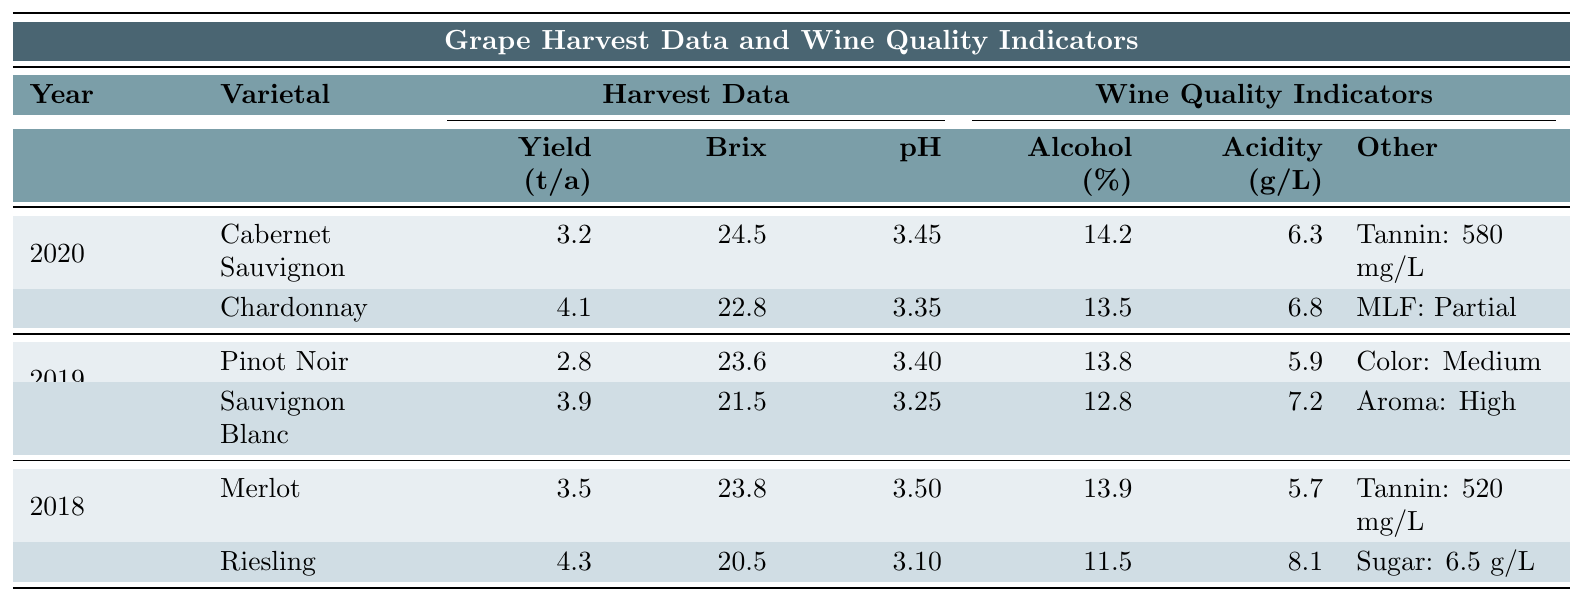What is the yield of Chardonnay in 2020? The yield for Chardonnay in 2020 is specifically listed in the table under the Harvest Data section for that varietal, which shows "Yield (tons/acre): 4.1".
Answer: 4.1 tons/acre What is the alcohol content of Pinot Noir in 2019? According to the table, the alcohol content for Pinot Noir in 2019 is provided as "Alcohol Content (%): 13.8".
Answer: 13.8% Was the Brix at harvest for Merlot in 2018 higher than 24? The Brix at harvest for Merlot is listed as 23.8, which means it is lower than 24. Therefore, the statement is false.
Answer: No Which varietal had the lowest total acidity in 2020? Comparing total acidity values from the table for varietals in 2020, Cabernet Sauvignon (6.3 g/L) has lower acidity than Chardonnay (6.8 g/L).
Answer: Cabernet Sauvignon What is the difference in yield between Sauvignon Blanc in 2019 and Riesling in 2018? The yield of Sauvignon Blanc in 2019 is 3.9 tons/acre, and the yield of Riesling in 2018 is 4.3 tons/acre. The difference is calculated as 4.3 - 3.9 = 0.4 tons/acre.
Answer: 0.4 tons/acre Does the alcohol content of Chardonnay in 2020 exceed that of Riesling in 2018? The alcohol content for Chardonnay in 2020 is 13.5%, while for Riesling in 2018 it is 11.5%. Since 13.5% is greater than 11.5%, the answer is yes.
Answer: Yes What is the average Brix at harvest for all varietals across the years 2018 to 2020? To find the average Brix, sum the Brix values for all varietals: 24.5 (Cabernet Sauvignon) + 22.8 (Chardonnay) + 23.6 (Pinot Noir) + 21.5 (Sauvignon Blanc) + 23.8 (Merlot) + 20.5 (Riesling) = 136.7. Then divide by the number of varietals, which is 6: 136.7 / 6 ≈ 22.78.
Answer: 22.78 Which varietal had the highest alcohol content in 2020? From the table, the alcohol contents are 14.2% for Cabernet Sauvignon and 13.5% for Chardonnay. Therefore, Cabernet Sauvignon has the highest alcohol content in that year.
Answer: Cabernet Sauvignon If the pH of Merlot in 2018 is compared to Chardonnay in 2020, which has the higher pH? Merlot's pH in 2018 is 3.50, while Chardonnay's pH in 2020 is 3.35. Since 3.50 is greater than 3.35, Merlot has the higher pH.
Answer: Merlot By how much does the total acidity of Riesling in 2018 exceed that of Pinot Noir in 2019? Riesling's total acidity is 8.1 g/L and Pinot Noir's total acidity is 5.9 g/L. The difference is 8.1 - 5.9 = 2.2 g/L, so Riesling exceeds Pinot Noir by this amount.
Answer: 2.2 g/L 